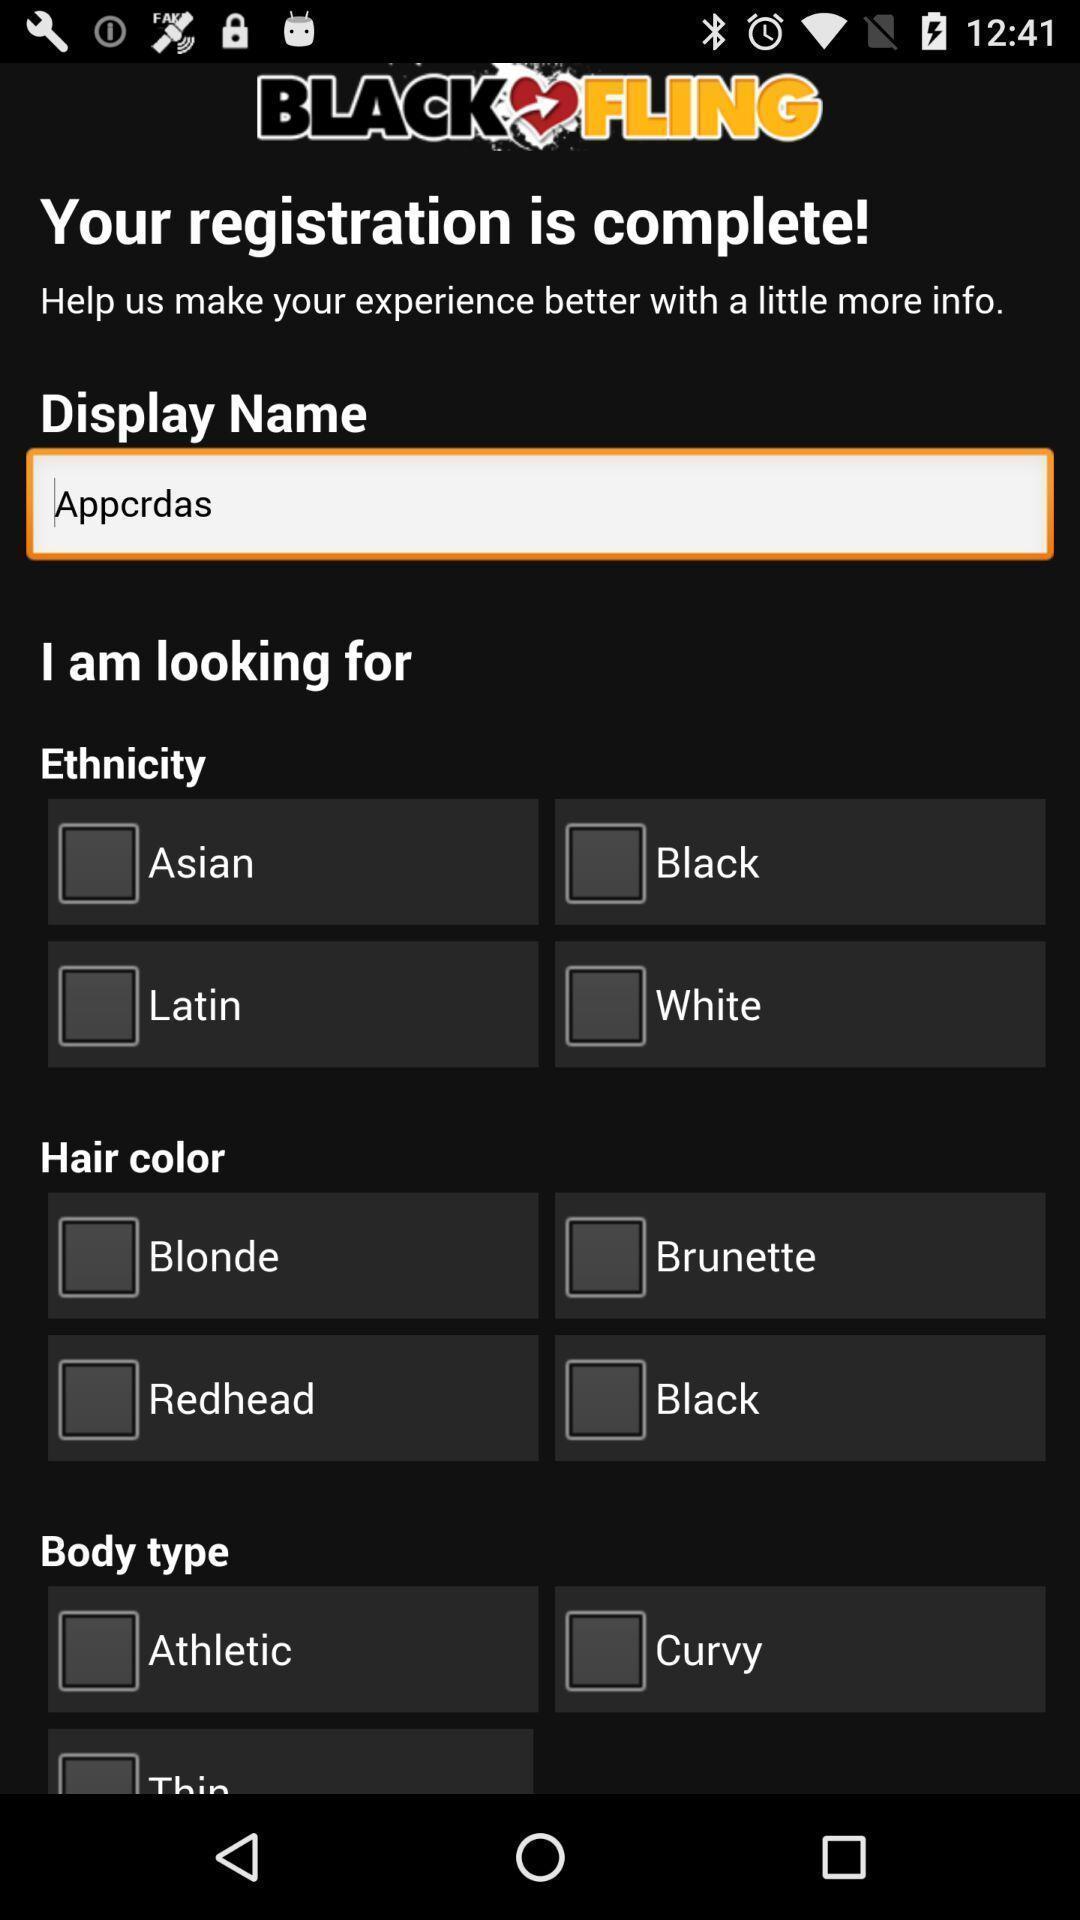Explain the elements present in this screenshot. Screen page displaying various options to select in dating app. 